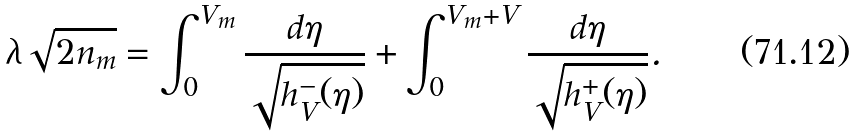Convert formula to latex. <formula><loc_0><loc_0><loc_500><loc_500>\lambda \sqrt { 2 n _ { m } } = \int _ { 0 } ^ { V _ { m } } \frac { d \eta } { \sqrt { h _ { V } ^ { - } ( \eta ) } } + \int _ { 0 } ^ { V _ { m } + V } \frac { d \eta } { \sqrt { h _ { V } ^ { + } ( \eta ) } } .</formula> 